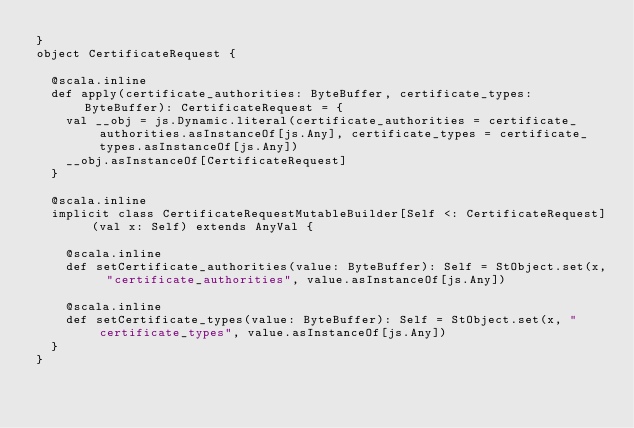Convert code to text. <code><loc_0><loc_0><loc_500><loc_500><_Scala_>}
object CertificateRequest {
  
  @scala.inline
  def apply(certificate_authorities: ByteBuffer, certificate_types: ByteBuffer): CertificateRequest = {
    val __obj = js.Dynamic.literal(certificate_authorities = certificate_authorities.asInstanceOf[js.Any], certificate_types = certificate_types.asInstanceOf[js.Any])
    __obj.asInstanceOf[CertificateRequest]
  }
  
  @scala.inline
  implicit class CertificateRequestMutableBuilder[Self <: CertificateRequest] (val x: Self) extends AnyVal {
    
    @scala.inline
    def setCertificate_authorities(value: ByteBuffer): Self = StObject.set(x, "certificate_authorities", value.asInstanceOf[js.Any])
    
    @scala.inline
    def setCertificate_types(value: ByteBuffer): Self = StObject.set(x, "certificate_types", value.asInstanceOf[js.Any])
  }
}
</code> 